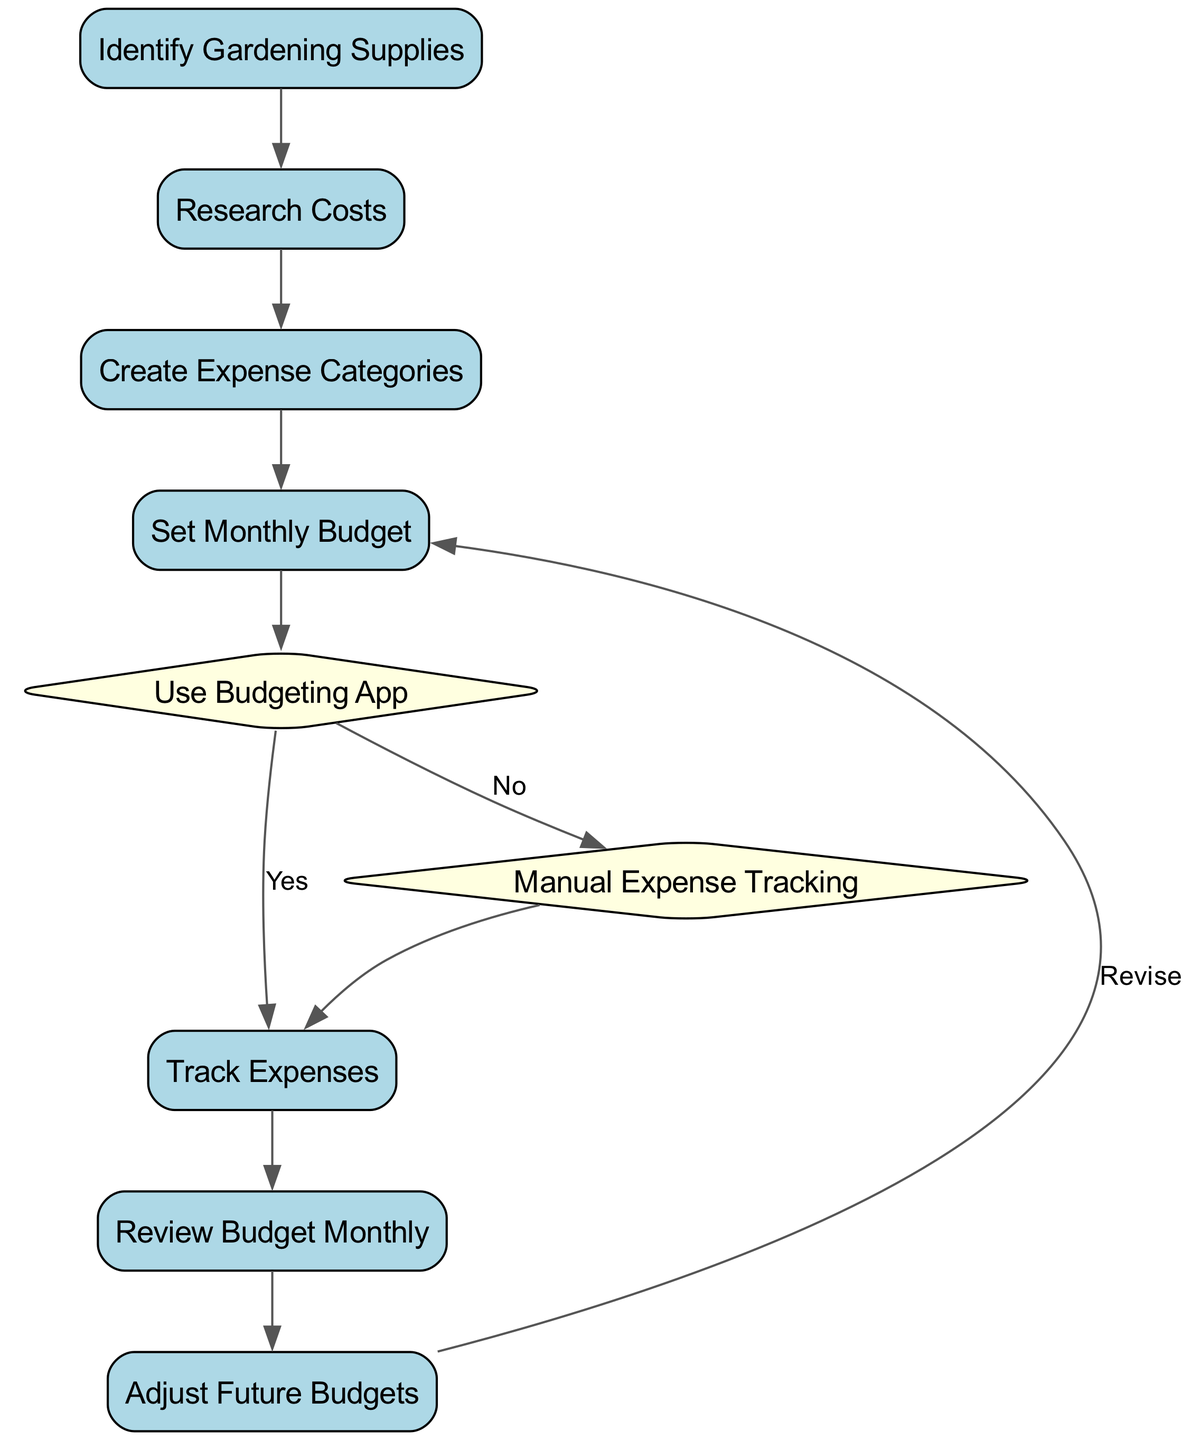What is the first step in the flow chart? The first step in the flow chart is "Identify Gardening Supplies," which is the initial process node that starts the budgeting and expense tracking sequence.
Answer: Identify Gardening Supplies How many decision nodes are there in the diagram? There are two decision nodes in the diagram: "Use Budgeting App" and "Manual Expense Tracking." These nodes represent choices that affect the subsequent steps.
Answer: 2 What comes after "Set Monthly Budget"? After "Set Monthly Budget," the next node is "Use Budgeting App," which is a decision point determining the following course of action in the diagram.
Answer: Use Budgeting App What action follows "Track Expenses"? The action that follows "Track Expenses" is "Review Budget Monthly," which indicates a monthly assessment of the expenses related to gardening supplies.
Answer: Review Budget Monthly If you choose "Manual Expense Tracking," what is the next step? If you choose "Manual Expense Tracking," the next step is to "Track Expenses," as indicated by the directed edge leading from that decision node back to the expense tracking action.
Answer: Track Expenses What is the last process in the flow chart? The last process in the flow chart is "Adjust Future Budgets," which is the final step that leads back to revisiting the monthly budget in a continuous improvement cycle.
Answer: Adjust Future Budgets What two paths can a user take after creating an expense category? After creating an expense category, a user can take one of two paths: either move to "Set Monthly Budget," or make a decision to "Use Budgeting App" or "Manual Expense Tracking," leading to different tracking methods.
Answer: Set Monthly Budget, Use Budgeting App / Manual Expense Tracking What happens if you select "No" at the "Use Budgeting App" decision? If you select "No" at the "Use Budgeting App" decision, you will proceed to "Manual Expense Tracking," which becomes the method for expense tracking instead of using an app.
Answer: Manual Expense Tracking 